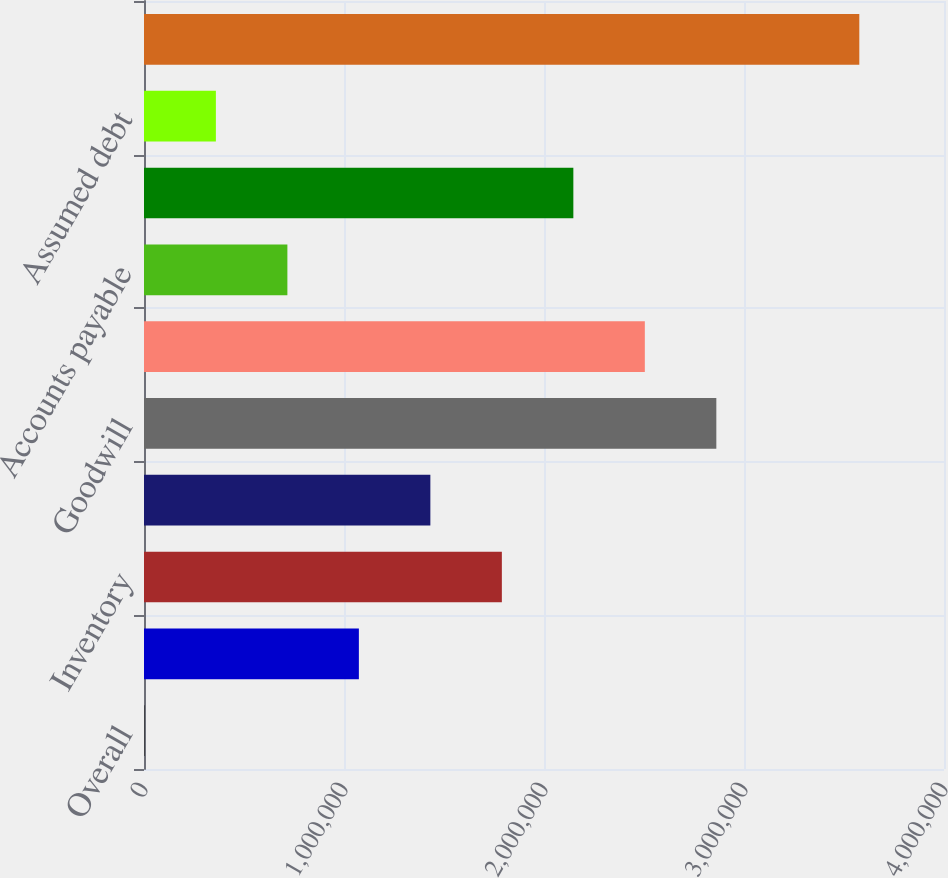Convert chart. <chart><loc_0><loc_0><loc_500><loc_500><bar_chart><fcel>Overall<fcel>Accounts receivable<fcel>Inventory<fcel>Property plant and equipment<fcel>Goodwill<fcel>Other intangible assets<fcel>Accounts payable<fcel>Other assets and liabilities<fcel>Assumed debt<fcel>Net cash consideration<nl><fcel>2007<fcel>1.07437e+06<fcel>1.78928e+06<fcel>1.43183e+06<fcel>2.86165e+06<fcel>2.5042e+06<fcel>716918<fcel>2.14674e+06<fcel>359462<fcel>3.57656e+06<nl></chart> 